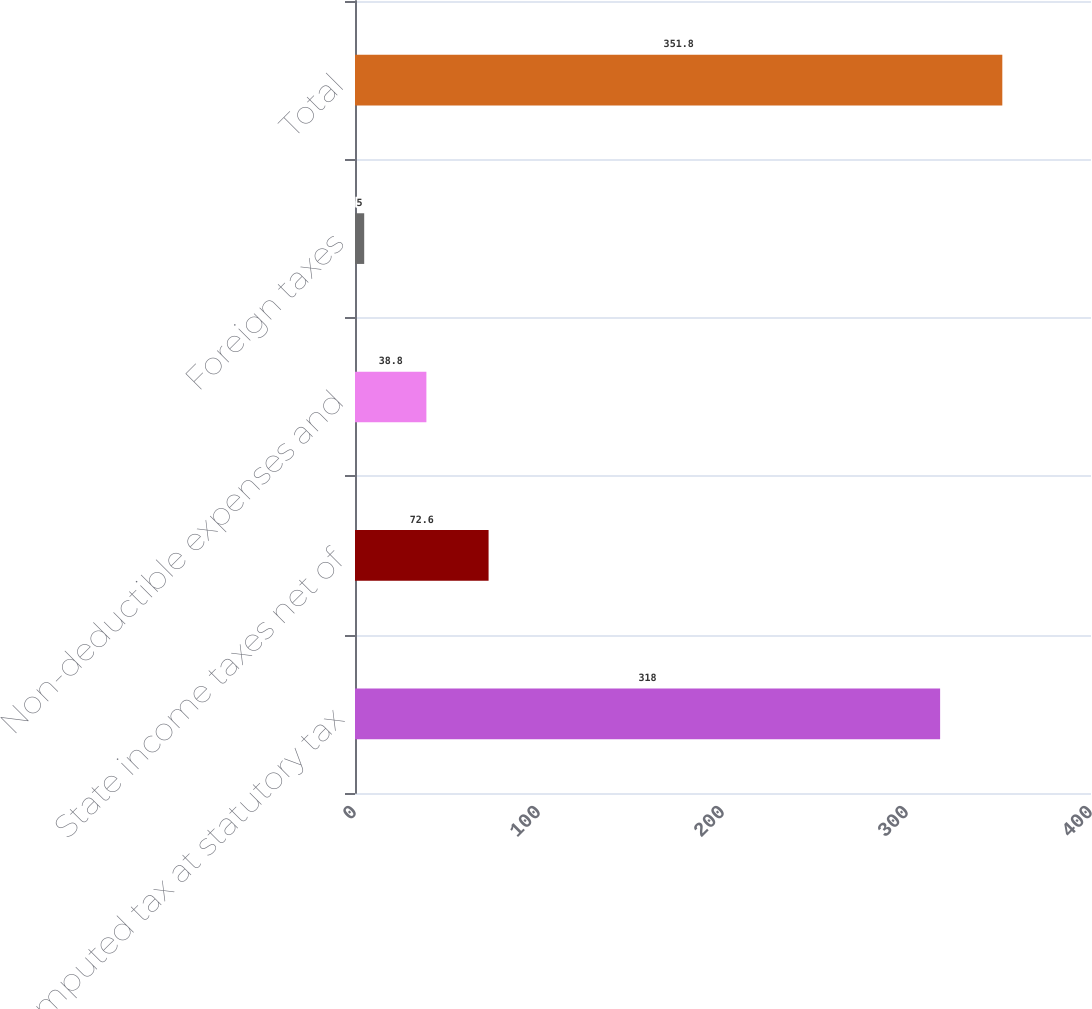Convert chart to OTSL. <chart><loc_0><loc_0><loc_500><loc_500><bar_chart><fcel>Computed tax at statutory tax<fcel>State income taxes net of<fcel>Non-deductible expenses and<fcel>Foreign taxes<fcel>Total<nl><fcel>318<fcel>72.6<fcel>38.8<fcel>5<fcel>351.8<nl></chart> 